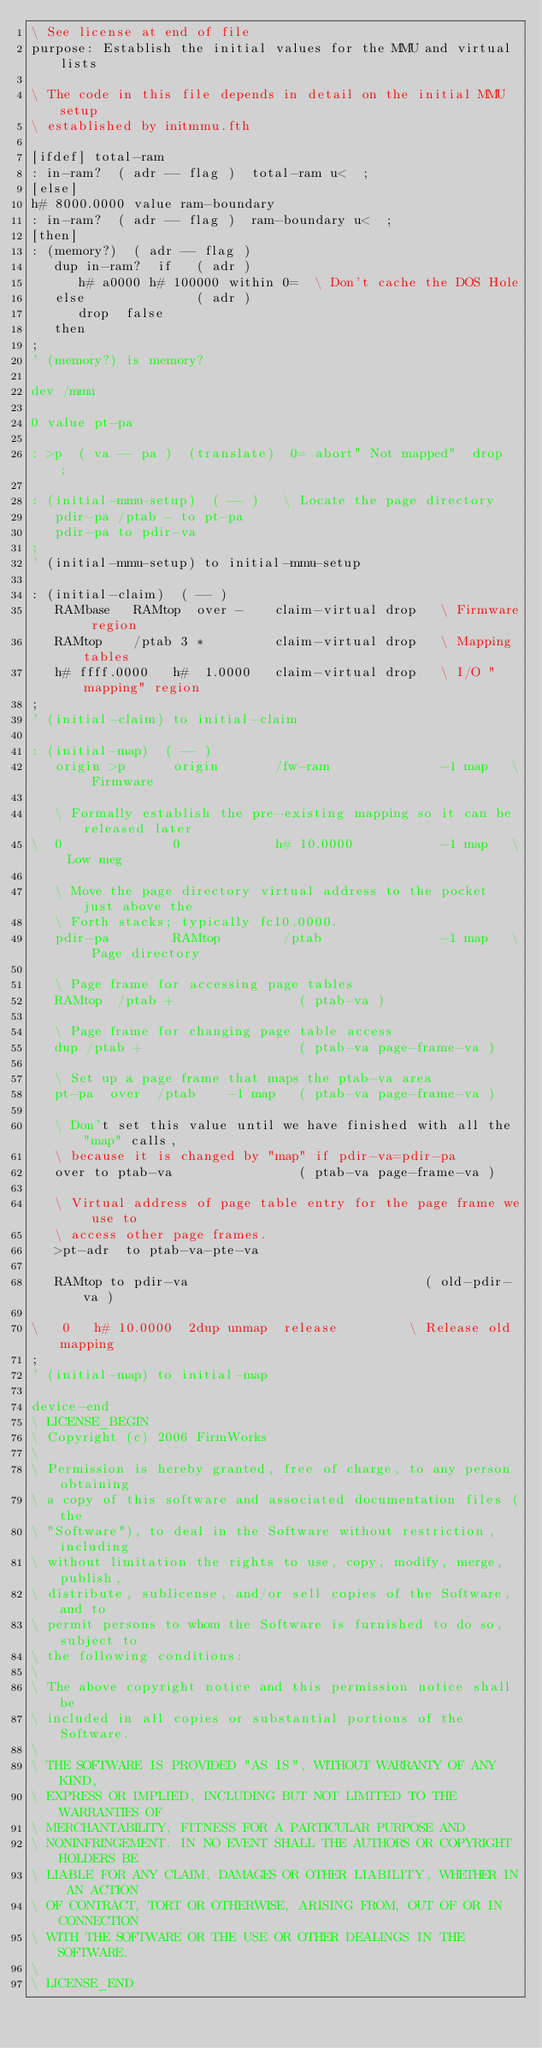<code> <loc_0><loc_0><loc_500><loc_500><_Forth_>\ See license at end of file
purpose: Establish the initial values for the MMU and virtual lists

\ The code in this file depends in detail on the initial MMU setup
\ established by initmmu.fth

[ifdef] total-ram
: in-ram?  ( adr -- flag )  total-ram u<  ;
[else]
h# 8000.0000 value ram-boundary
: in-ram?  ( adr -- flag )  ram-boundary u<  ;
[then]
: (memory?)  ( adr -- flag )
   dup in-ram?  if   ( adr )
      h# a0000 h# 100000 within 0=  \ Don't cache the DOS Hole
   else              ( adr )
      drop  false
   then
;
' (memory?) is memory?

dev /mmu

0 value pt-pa

: >p  ( va -- pa )  (translate)  0= abort" Not mapped"  drop  ;

: (initial-mmu-setup)  ( -- )	\ Locate the page directory
   pdir-pa /ptab - to pt-pa
   pdir-pa to pdir-va
;
' (initial-mmu-setup) to initial-mmu-setup

: (initial-claim)  ( -- )
   RAMbase   RAMtop  over -    claim-virtual drop   \ Firmware region
   RAMtop    /ptab 3 *         claim-virtual drop   \ Mapping tables
   h# ffff.0000   h#  1.0000   claim-virtual drop   \ I/O "mapping" region
;
' (initial-claim) to initial-claim

: (initial-map)  ( -- )
   origin >p      origin       /fw-ram              -1 map   \ Firmware 

   \ Formally establish the pre-existing mapping so it can be released later
\  0              0            h# 10.0000           -1 map   \ Low meg

   \ Move the page directory virtual address to the pocket just above the
   \ Forth stacks; typically fc10.0000.
   pdir-pa        RAMtop        /ptab               -1 map   \ Page directory

   \ Page frame for accessing page tables
   RAMtop  /ptab +                ( ptab-va )	

   \ Page frame for changing page table access
   dup /ptab +                    ( ptab-va page-frame-va )

   \ Set up a page frame that maps the ptab-va area
   pt-pa  over  /ptab    -1 map   ( ptab-va page-frame-va )

   \ Don't set this value until we have finished with all the "map" calls,
   \ because it is changed by "map" if pdir-va=pdir-pa
   over to ptab-va                ( ptab-va page-frame-va )

   \ Virtual address of page table entry for the page frame we use to
   \ access other page frames.
   >pt-adr  to ptab-va-pte-va

   RAMtop to pdir-va                              ( old-pdir-va )

\   0   h# 10.0000  2dup unmap 	release			\ Release old mapping
;
' (initial-map) to initial-map

device-end
\ LICENSE_BEGIN
\ Copyright (c) 2006 FirmWorks
\ 
\ Permission is hereby granted, free of charge, to any person obtaining
\ a copy of this software and associated documentation files (the
\ "Software"), to deal in the Software without restriction, including
\ without limitation the rights to use, copy, modify, merge, publish,
\ distribute, sublicense, and/or sell copies of the Software, and to
\ permit persons to whom the Software is furnished to do so, subject to
\ the following conditions:
\ 
\ The above copyright notice and this permission notice shall be
\ included in all copies or substantial portions of the Software.
\ 
\ THE SOFTWARE IS PROVIDED "AS IS", WITHOUT WARRANTY OF ANY KIND,
\ EXPRESS OR IMPLIED, INCLUDING BUT NOT LIMITED TO THE WARRANTIES OF
\ MERCHANTABILITY, FITNESS FOR A PARTICULAR PURPOSE AND
\ NONINFRINGEMENT. IN NO EVENT SHALL THE AUTHORS OR COPYRIGHT HOLDERS BE
\ LIABLE FOR ANY CLAIM, DAMAGES OR OTHER LIABILITY, WHETHER IN AN ACTION
\ OF CONTRACT, TORT OR OTHERWISE, ARISING FROM, OUT OF OR IN CONNECTION
\ WITH THE SOFTWARE OR THE USE OR OTHER DEALINGS IN THE SOFTWARE.
\
\ LICENSE_END
</code> 